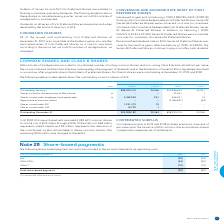According to Bce's financial document, How many common shares did BCE repurchase in 2018? According to the financial document, 3,085,697. The relevant text states: "Repurchase of common shares – – (3,085,697) (69)..." Also, What is the amount of stated capital outstanding on December 31, 2019 According to the financial document, 20,363. The relevant text states: "Outstanding, December 31 903,908,182 20,363 898,200,415 20,036..." Also, What comprised of the total cost that went into the repurchase of common shares in 2018? The document contains multiple relevant values: Stated capital, reduction of the contributed surplus attributable to these common shares, charged to the deficit. From the document: "ents stated capital and $3 million represents the reduction of the contributed surplus attributable to these common shares. The remaining $103 million..." Also, can you calculate: What is the percentage of the value charged to the deficit expressed as a percentage of total cost of common shares? Based on the calculation: 103/175, the result is 58.86 (percentage). This is based on the information: "tributable to these common shares. The remaining $103 million was charged to the deficit. eled 3,085,697 common shares for a total cost of $175 million through a NCIB. Of the total cost, $69 million r..." The key data points involved are: 103, 175. Also, can you calculate: What was the total number of shares issued under ESP and DSP in 2019? Based on the calculation: 1,231,479+16,729, the result is 1248208. This is based on the information: "Shares issued under DSP 16,729 1 – – Shares issued under ESP 1,231,479 75 – –..." The key data points involved are: 1,231,479, 16,729. Also, can you calculate: What is the percentage change in the total number of shares in 2019? To answer this question, I need to perform calculations using the financial data. The calculation is: (898,200,415-900,996,640)/900,996,640, which equals -0.31 (percentage). This is based on the information: "Outstanding, January 1 898,200,415 20,036 900,996,640 20,091 Outstanding, January 1 898,200,415 20,036 900,996,640 20,091..." The key data points involved are: 898,200,415, 900,996,640. 